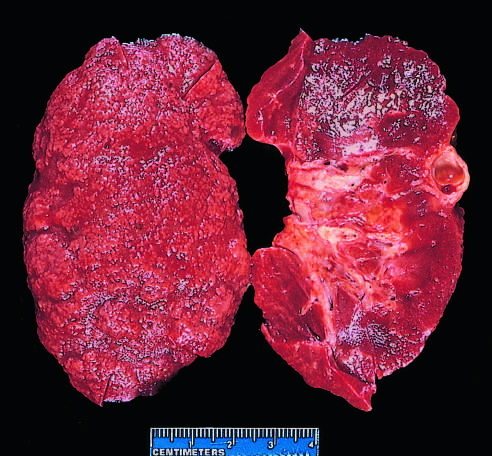does the bisected kidney demonstrate diffuse granular transformation of the surface and marked thinning of the cortex (right)?
Answer the question using a single word or phrase. Yes 